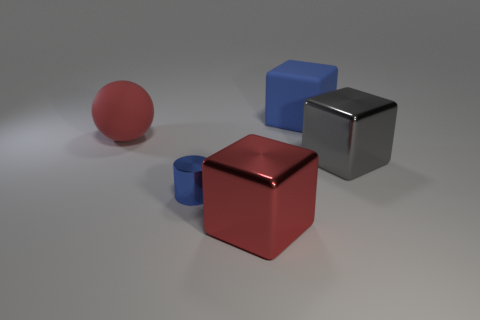Is the shape of the big thing in front of the blue shiny cylinder the same as  the tiny thing?
Offer a terse response. No. There is a rubber object that is on the right side of the large matte ball; what is its color?
Keep it short and to the point. Blue. What is the shape of the small thing that is made of the same material as the red cube?
Your answer should be very brief. Cylinder. Are there any other things of the same color as the big sphere?
Keep it short and to the point. Yes. Are there more big rubber spheres that are behind the large red rubber ball than small metallic cylinders that are behind the cylinder?
Give a very brief answer. No. What number of gray cubes are the same size as the red block?
Your response must be concise. 1. Are there fewer blue metal cylinders that are right of the small blue metallic object than gray objects that are behind the large gray metallic block?
Make the answer very short. No. Is there a blue shiny thing that has the same shape as the big gray shiny thing?
Offer a very short reply. No. Is the shape of the red shiny object the same as the blue rubber thing?
Ensure brevity in your answer.  Yes. How many big objects are either gray cubes or cubes?
Provide a short and direct response. 3. 